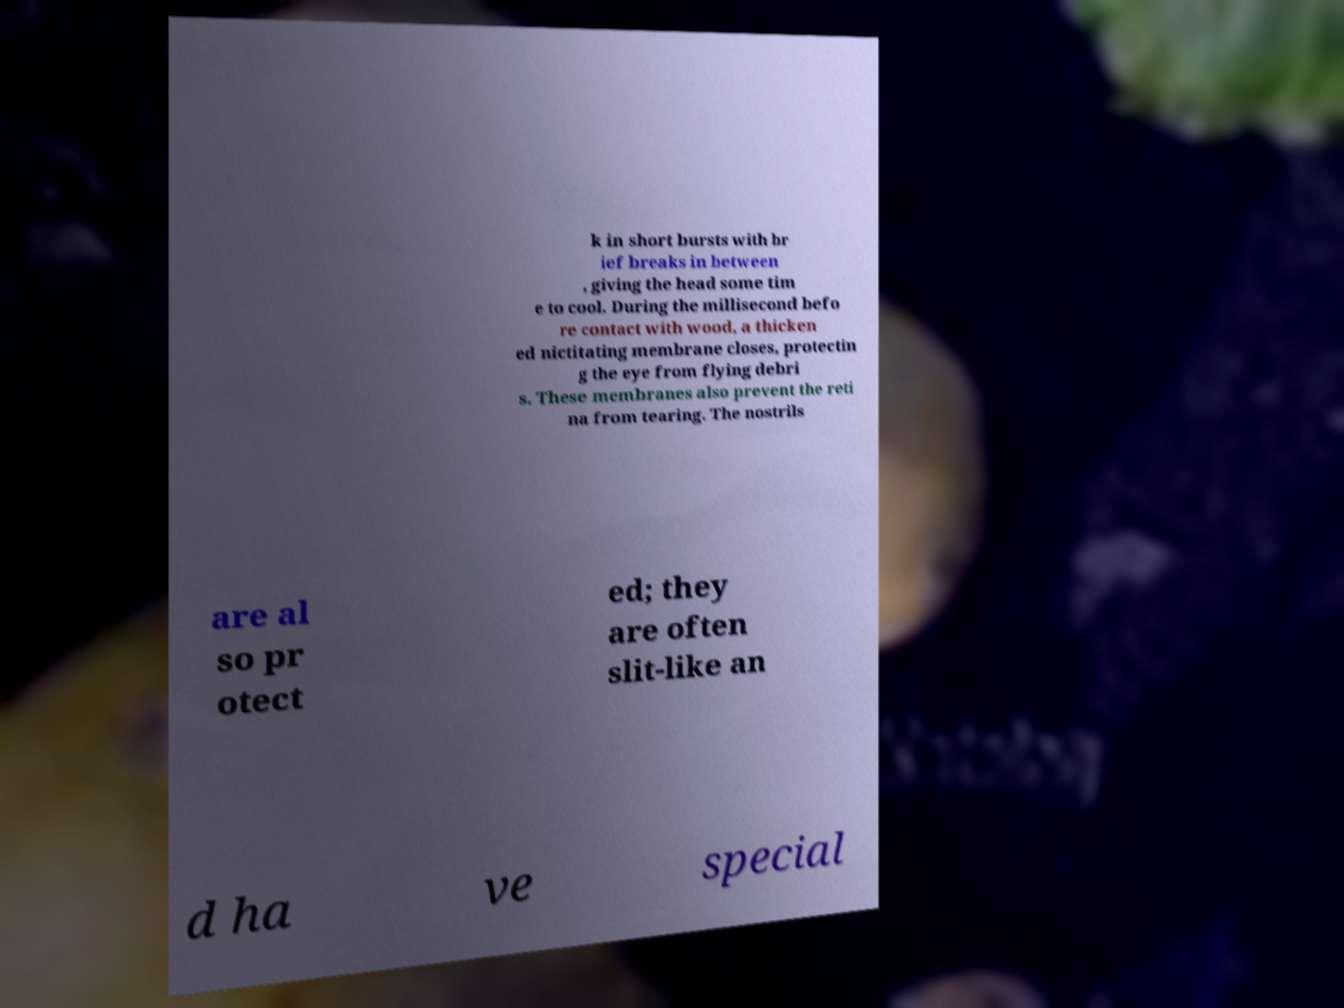Could you extract and type out the text from this image? k in short bursts with br ief breaks in between , giving the head some tim e to cool. During the millisecond befo re contact with wood, a thicken ed nictitating membrane closes, protectin g the eye from flying debri s. These membranes also prevent the reti na from tearing. The nostrils are al so pr otect ed; they are often slit-like an d ha ve special 